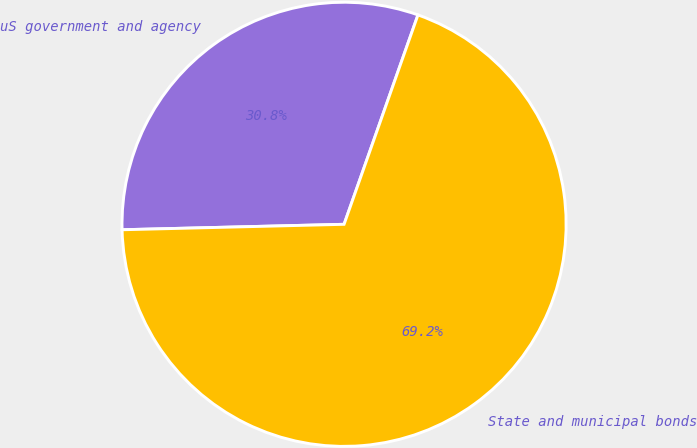<chart> <loc_0><loc_0><loc_500><loc_500><pie_chart><fcel>uS government and agency<fcel>State and municipal bonds<nl><fcel>30.79%<fcel>69.21%<nl></chart> 